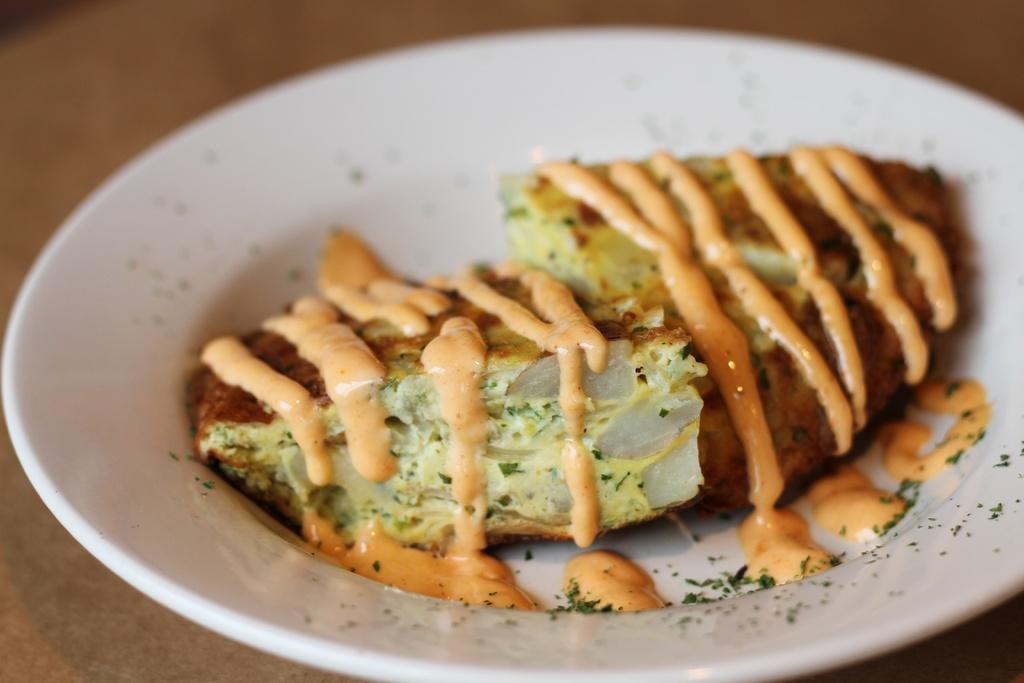What is the main subject of the image? There is a food item in the image. Can you describe the plate on which the food item is placed? The food item is on a white color plate. What type of field can be seen in the background of the image? There is no field visible in the image; it only features a food item on a white color plate. 